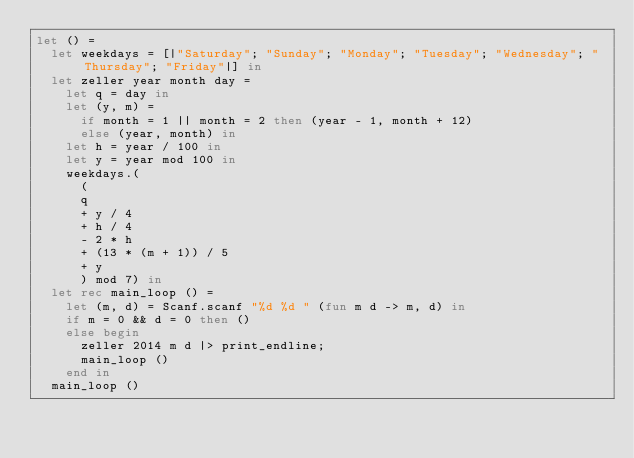<code> <loc_0><loc_0><loc_500><loc_500><_OCaml_>let () =
  let weekdays = [|"Saturday"; "Sunday"; "Monday"; "Tuesday"; "Wednesday"; "Thursday"; "Friday"|] in
  let zeller year month day =
    let q = day in
    let (y, m) =
      if month = 1 || month = 2 then (year - 1, month + 12)
      else (year, month) in
    let h = year / 100 in
    let y = year mod 100 in
    weekdays.(
      (
      q
      + y / 4
      + h / 4
      - 2 * h
      + (13 * (m + 1)) / 5
      + y
      ) mod 7) in
  let rec main_loop () =
    let (m, d) = Scanf.scanf "%d %d " (fun m d -> m, d) in
    if m = 0 && d = 0 then ()
    else begin
      zeller 2014 m d |> print_endline;
      main_loop ()
    end in
  main_loop ()</code> 